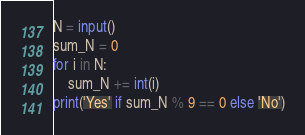<code> <loc_0><loc_0><loc_500><loc_500><_Python_>N = input()
sum_N = 0
for i in N:
    sum_N += int(i)
print('Yes' if sum_N % 9 == 0 else 'No')
</code> 